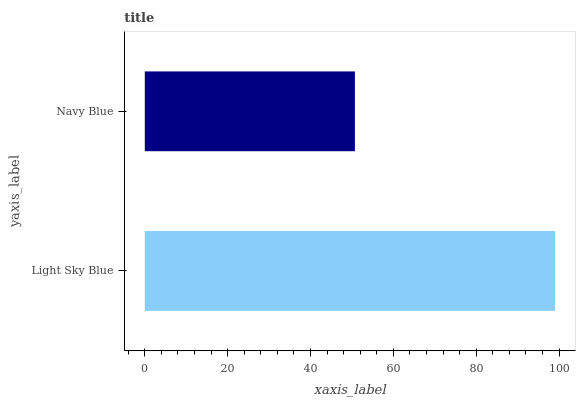Is Navy Blue the minimum?
Answer yes or no. Yes. Is Light Sky Blue the maximum?
Answer yes or no. Yes. Is Navy Blue the maximum?
Answer yes or no. No. Is Light Sky Blue greater than Navy Blue?
Answer yes or no. Yes. Is Navy Blue less than Light Sky Blue?
Answer yes or no. Yes. Is Navy Blue greater than Light Sky Blue?
Answer yes or no. No. Is Light Sky Blue less than Navy Blue?
Answer yes or no. No. Is Light Sky Blue the high median?
Answer yes or no. Yes. Is Navy Blue the low median?
Answer yes or no. Yes. Is Navy Blue the high median?
Answer yes or no. No. Is Light Sky Blue the low median?
Answer yes or no. No. 